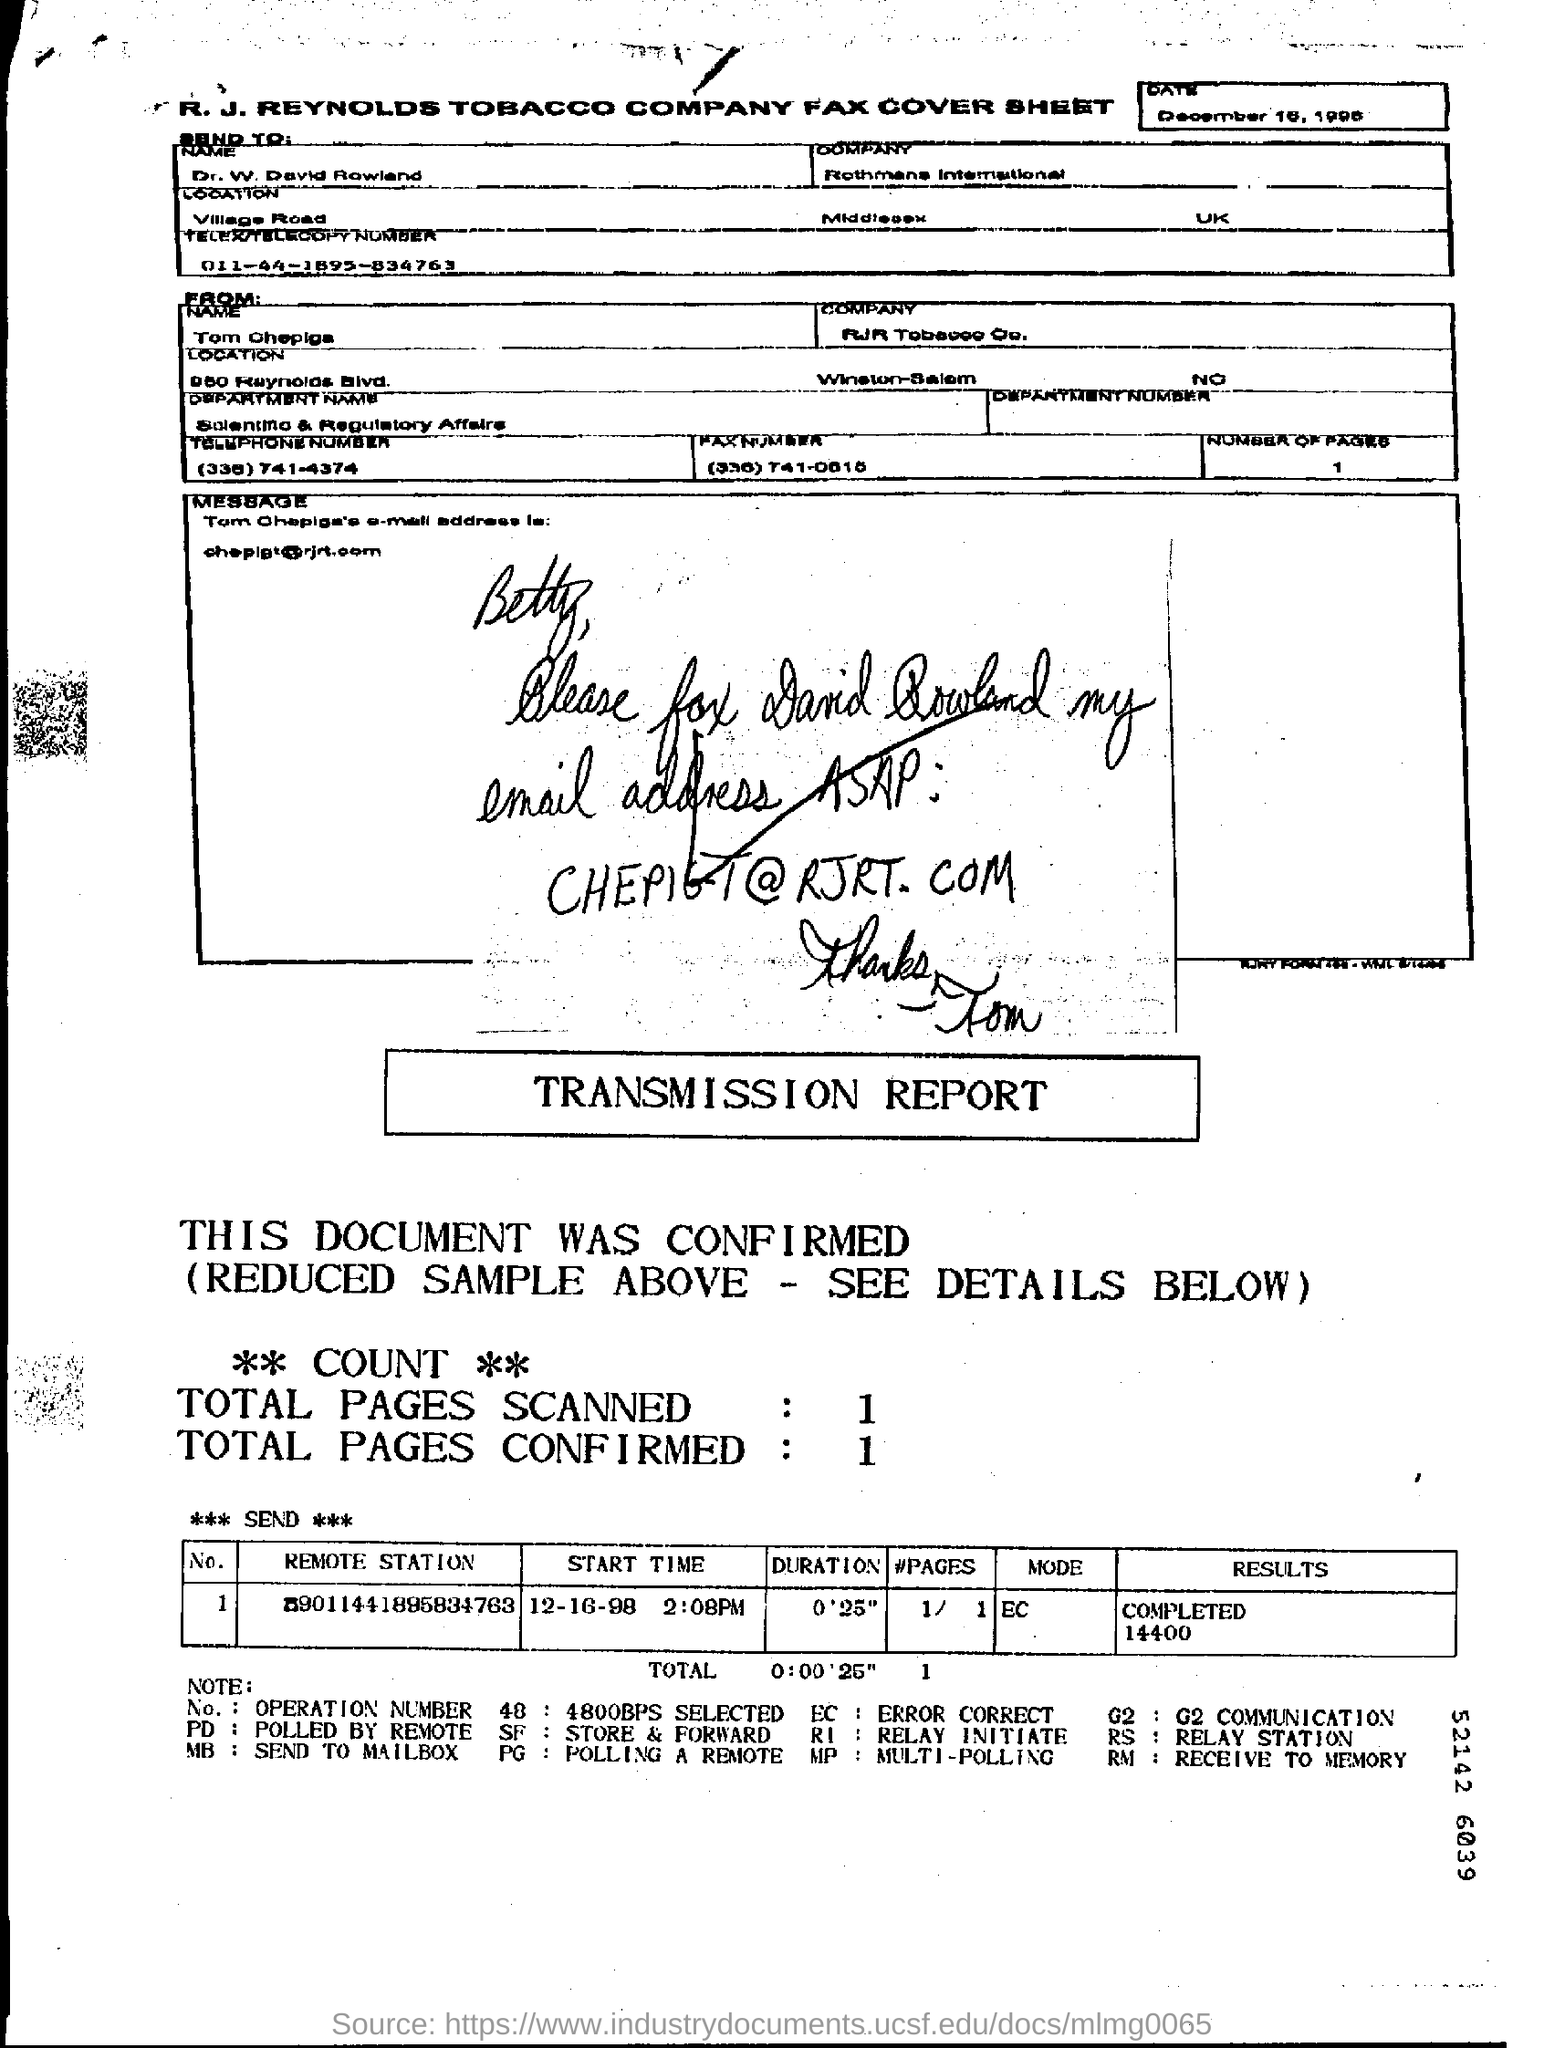What are the Total Pages Confirmed?
 1 